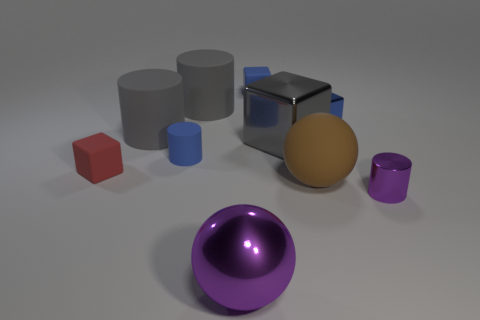There is a cylinder that is the same color as the metal ball; what is its size?
Your answer should be compact. Small. Do the big metallic thing that is in front of the red block and the red rubber object have the same shape?
Your answer should be compact. No. What is the material of the tiny blue thing that is left of the purple metallic ball?
Keep it short and to the point. Rubber. What shape is the small object that is the same color as the metal sphere?
Make the answer very short. Cylinder. Are there any big gray balls that have the same material as the tiny blue cylinder?
Your response must be concise. No. What size is the metallic ball?
Your answer should be compact. Large. How many purple things are either tiny metallic cylinders or cubes?
Offer a terse response. 1. What number of other large metal objects have the same shape as the large purple object?
Offer a very short reply. 0. What number of purple matte cubes are the same size as the brown thing?
Provide a succinct answer. 0. There is another large object that is the same shape as the large brown rubber thing; what is it made of?
Your answer should be very brief. Metal. 